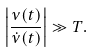<formula> <loc_0><loc_0><loc_500><loc_500>\left | \frac { \nu ( t ) } { \dot { \nu } ( t ) } \right | \gg T .</formula> 